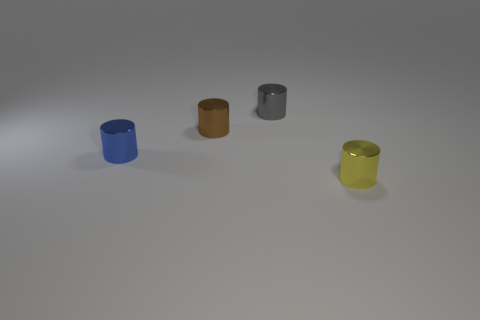The object that is behind the brown cylinder has what shape? The object located behind the brown cylinder appears to be another cylinder, evidenced by its circular base and elongated, uniform structure. 